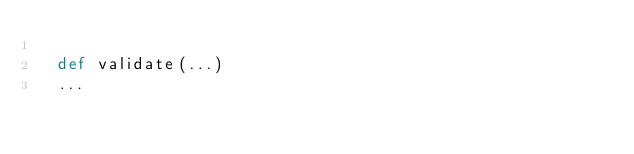Convert code to text. <code><loc_0><loc_0><loc_500><loc_500><_Python_>
	def validate(...)
	...
</code> 